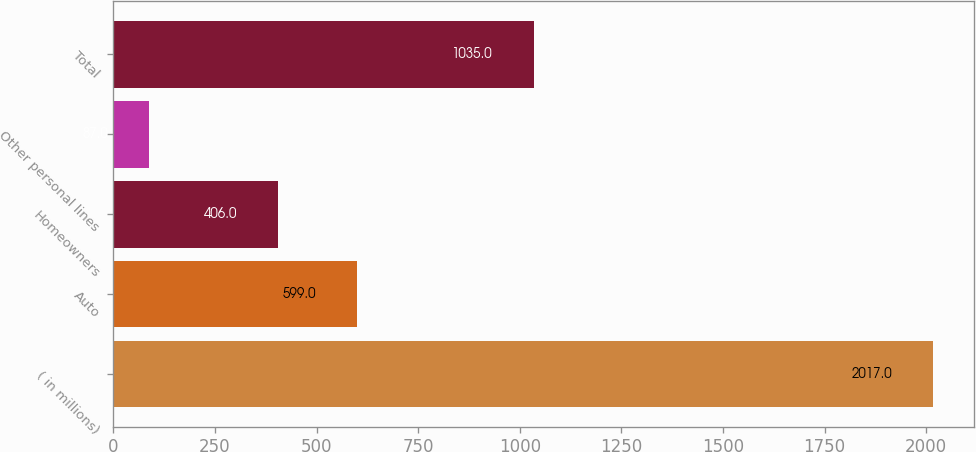Convert chart to OTSL. <chart><loc_0><loc_0><loc_500><loc_500><bar_chart><fcel>( in millions)<fcel>Auto<fcel>Homeowners<fcel>Other personal lines<fcel>Total<nl><fcel>2017<fcel>599<fcel>406<fcel>87<fcel>1035<nl></chart> 